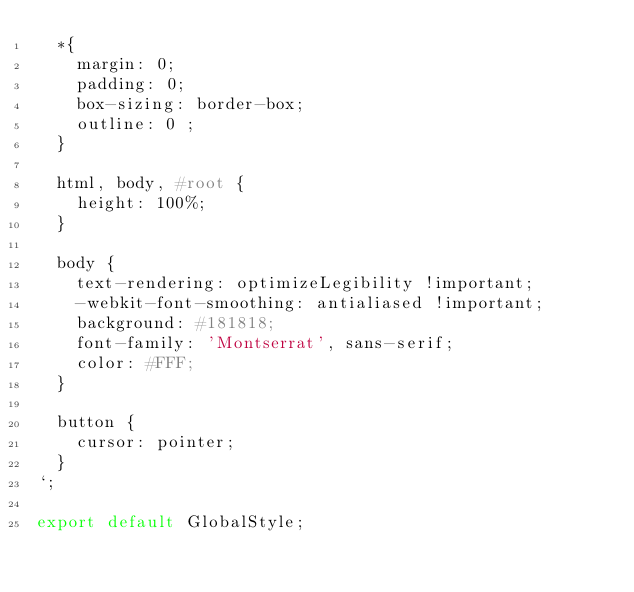Convert code to text. <code><loc_0><loc_0><loc_500><loc_500><_JavaScript_>  *{
    margin: 0;
    padding: 0;
    box-sizing: border-box;
    outline: 0 ;
  }

  html, body, #root {
    height: 100%;
  }

  body {
    text-rendering: optimizeLegibility !important;
    -webkit-font-smoothing: antialiased !important;
    background: #181818;
    font-family: 'Montserrat', sans-serif;
    color: #FFF;
  }

  button {
    cursor: pointer;
  }
`;

export default GlobalStyle;
</code> 